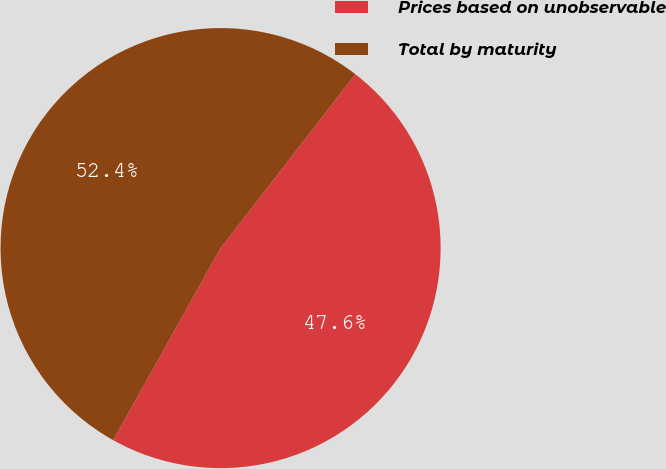Convert chart to OTSL. <chart><loc_0><loc_0><loc_500><loc_500><pie_chart><fcel>Prices based on unobservable<fcel>Total by maturity<nl><fcel>47.62%<fcel>52.38%<nl></chart> 